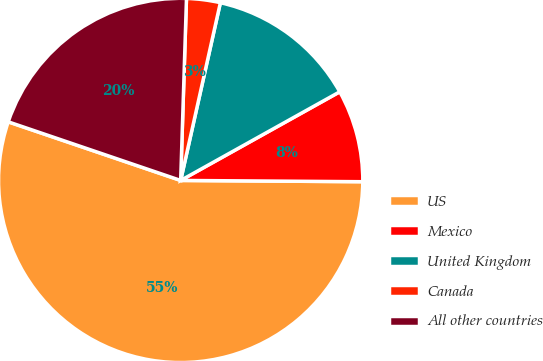Convert chart to OTSL. <chart><loc_0><loc_0><loc_500><loc_500><pie_chart><fcel>US<fcel>Mexico<fcel>United Kingdom<fcel>Canada<fcel>All other countries<nl><fcel>55.1%<fcel>8.2%<fcel>13.41%<fcel>2.99%<fcel>20.29%<nl></chart> 